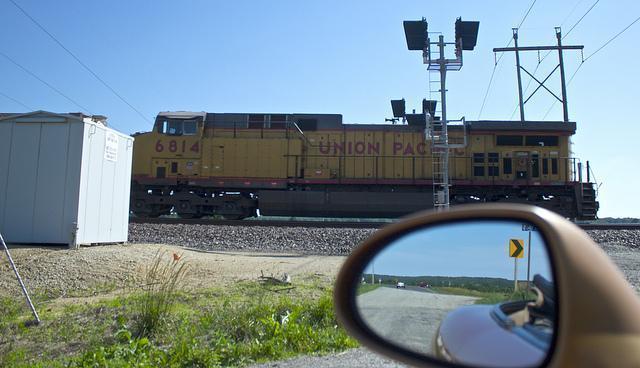How many people are carrying surfboards?
Give a very brief answer. 0. 